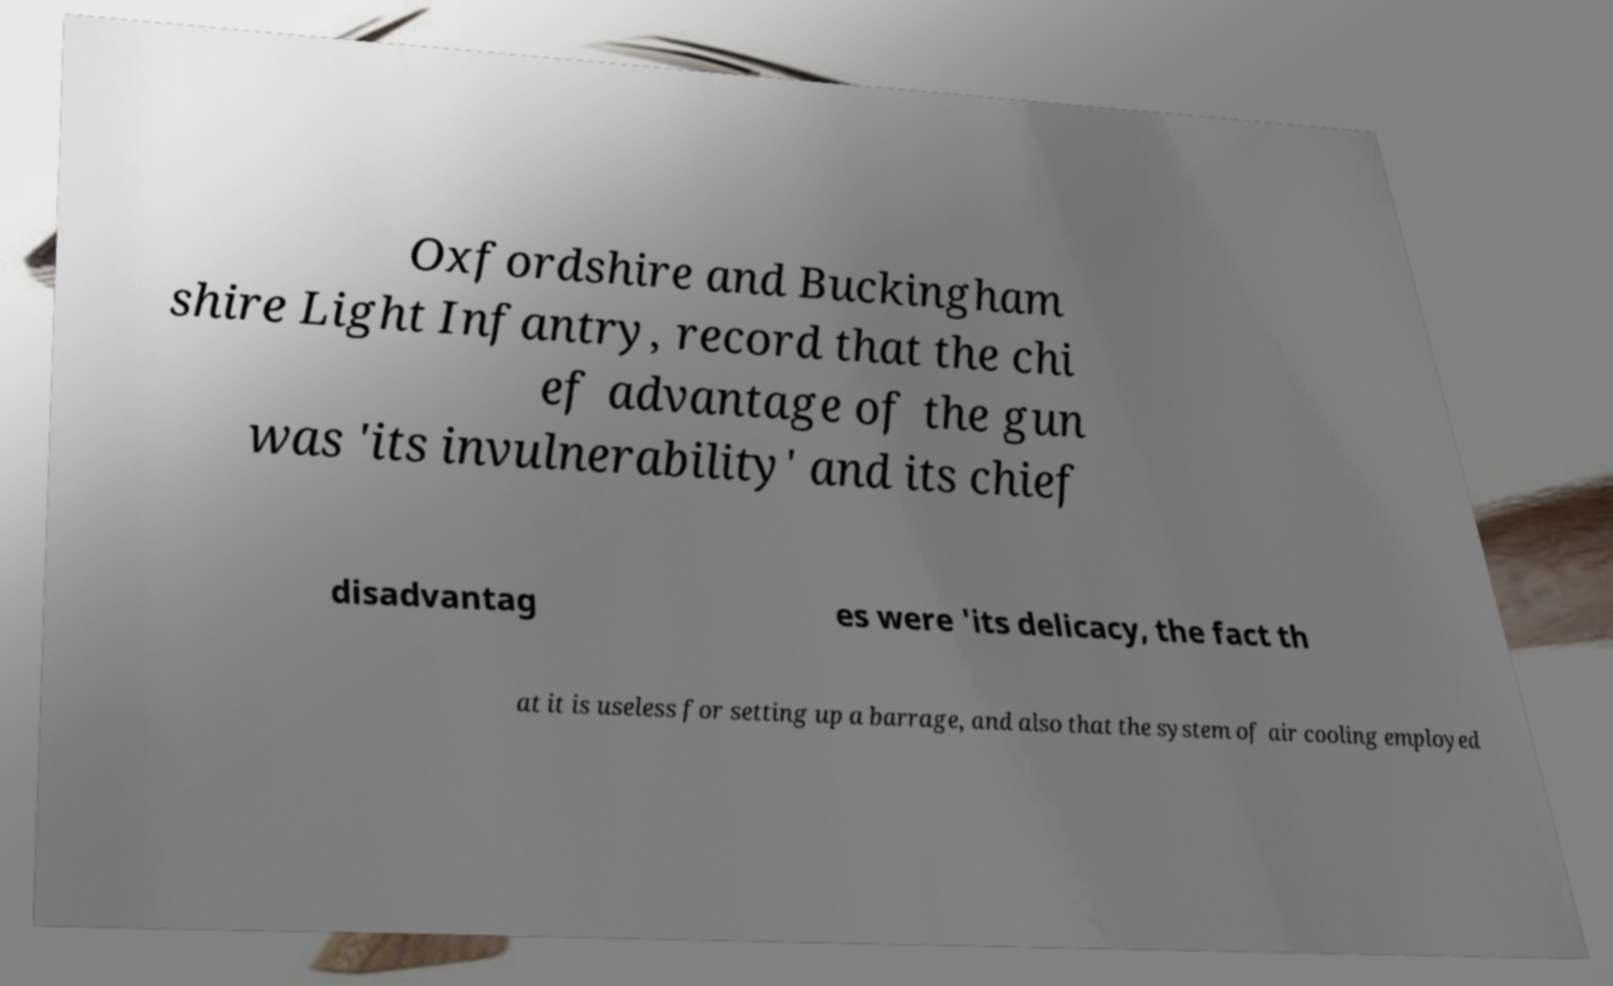Please identify and transcribe the text found in this image. Oxfordshire and Buckingham shire Light Infantry, record that the chi ef advantage of the gun was 'its invulnerability' and its chief disadvantag es were 'its delicacy, the fact th at it is useless for setting up a barrage, and also that the system of air cooling employed 